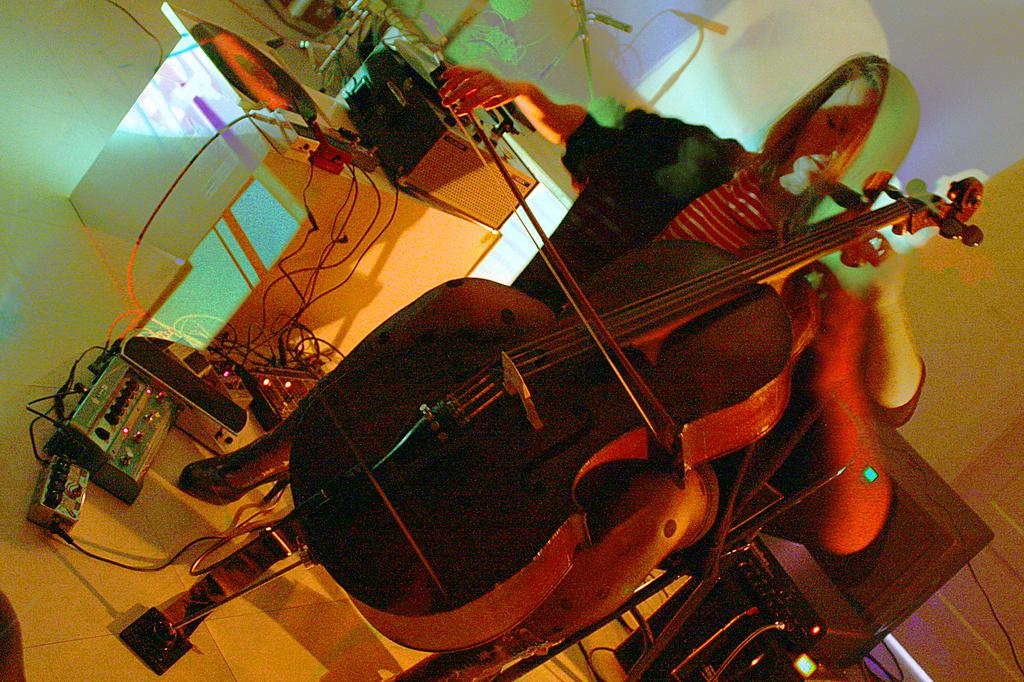Who is the main subject in the image? There is a girl in the image. What is the girl doing in the image? The girl is sitting on a chair and playing a violin. What else can be seen in the image besides the girl? There is a table in the image, and sound boxes are arranged on the side of the table. How many potatoes can be seen on the table in the image? There are no potatoes present in the image; the table has sound boxes arranged on its side. 